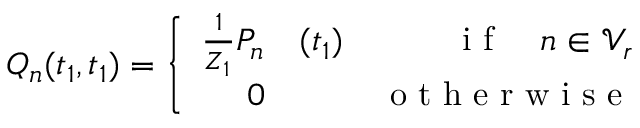<formula> <loc_0><loc_0><loc_500><loc_500>Q _ { n } ( t _ { 1 } , t _ { 1 } ) = \left \{ \begin{array} { r l r } { \frac { 1 } { Z _ { 1 } } P _ { n } } & ( t _ { 1 } ) } & { i f \quad n \in \mathcal { V } _ { r } } \\ { 0 } & { o t h e r w i s e } \end{array}</formula> 